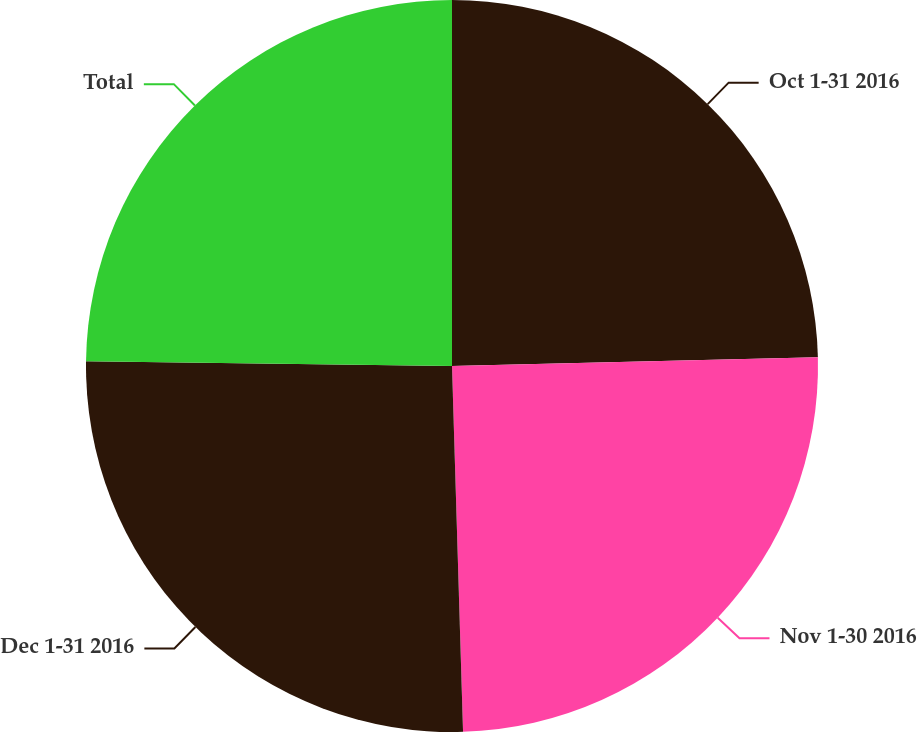Convert chart to OTSL. <chart><loc_0><loc_0><loc_500><loc_500><pie_chart><fcel>Oct 1-31 2016<fcel>Nov 1-30 2016<fcel>Dec 1-31 2016<fcel>Total<nl><fcel>24.62%<fcel>24.9%<fcel>25.69%<fcel>24.79%<nl></chart> 